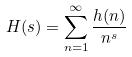<formula> <loc_0><loc_0><loc_500><loc_500>H ( s ) = \sum _ { n = 1 } ^ { \infty } \frac { h ( n ) } { n ^ { s } }</formula> 